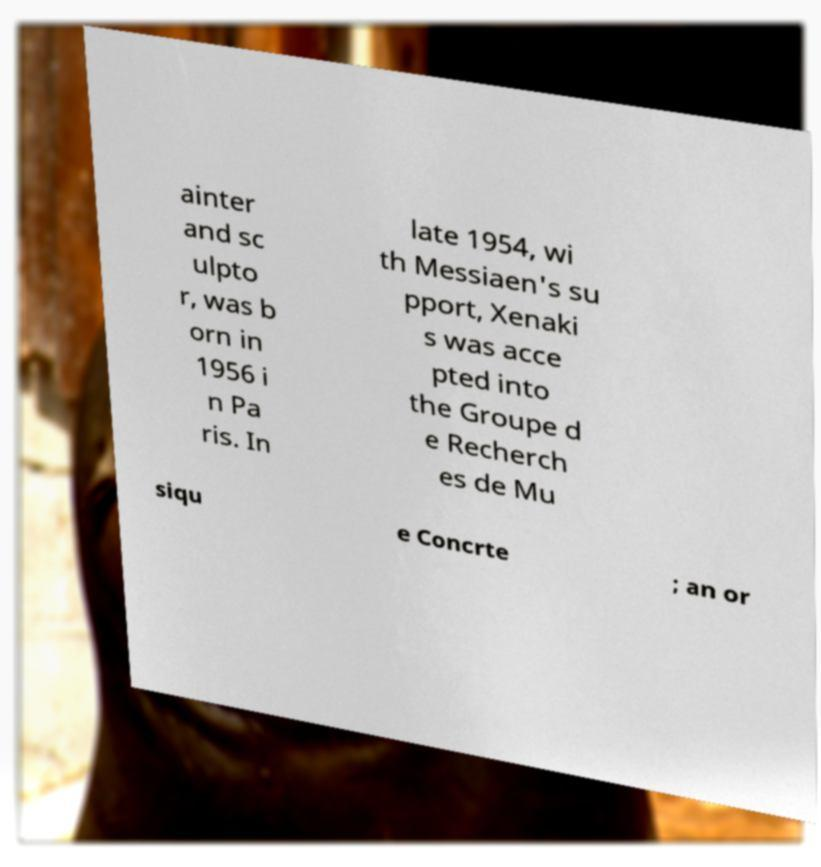For documentation purposes, I need the text within this image transcribed. Could you provide that? ainter and sc ulpto r, was b orn in 1956 i n Pa ris. In late 1954, wi th Messiaen's su pport, Xenaki s was acce pted into the Groupe d e Recherch es de Mu siqu e Concrte ; an or 